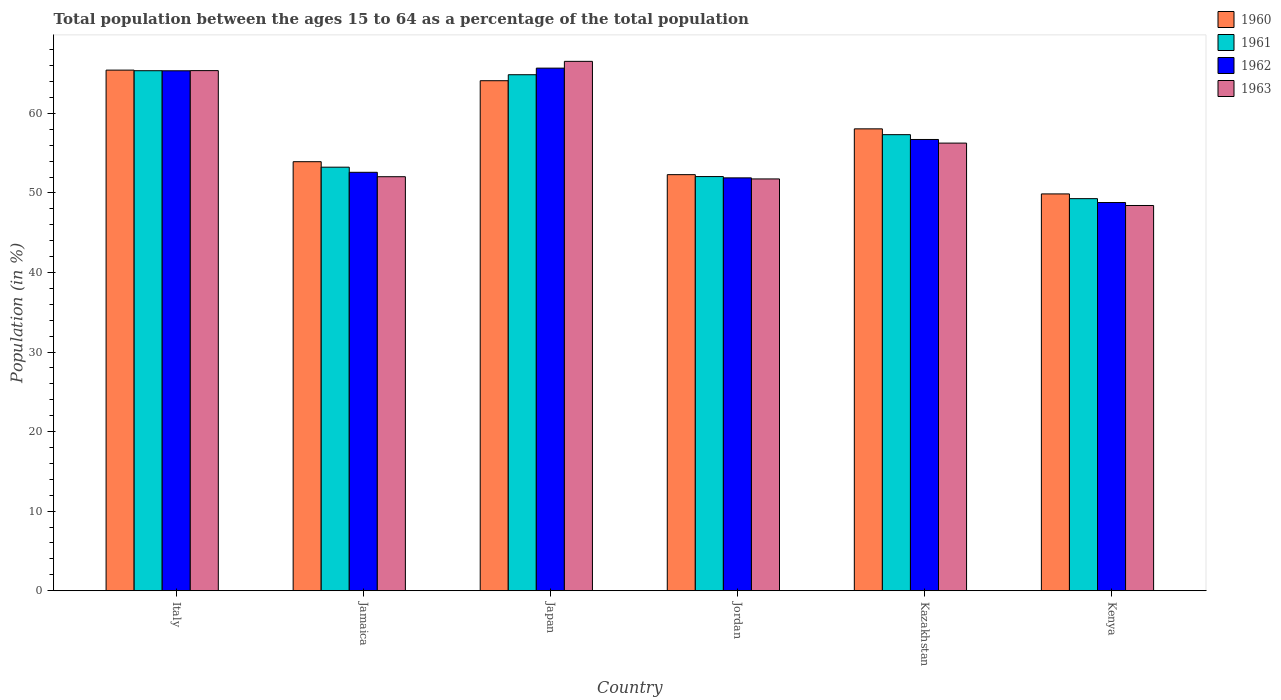How many different coloured bars are there?
Your answer should be compact. 4. Are the number of bars per tick equal to the number of legend labels?
Provide a short and direct response. Yes. How many bars are there on the 6th tick from the left?
Keep it short and to the point. 4. How many bars are there on the 2nd tick from the right?
Ensure brevity in your answer.  4. What is the label of the 5th group of bars from the left?
Make the answer very short. Kazakhstan. In how many cases, is the number of bars for a given country not equal to the number of legend labels?
Provide a short and direct response. 0. What is the percentage of the population ages 15 to 64 in 1960 in Jordan?
Give a very brief answer. 52.31. Across all countries, what is the maximum percentage of the population ages 15 to 64 in 1962?
Your response must be concise. 65.7. Across all countries, what is the minimum percentage of the population ages 15 to 64 in 1960?
Give a very brief answer. 49.88. In which country was the percentage of the population ages 15 to 64 in 1962 minimum?
Your answer should be very brief. Kenya. What is the total percentage of the population ages 15 to 64 in 1963 in the graph?
Ensure brevity in your answer.  340.45. What is the difference between the percentage of the population ages 15 to 64 in 1963 in Japan and that in Kazakhstan?
Give a very brief answer. 10.28. What is the difference between the percentage of the population ages 15 to 64 in 1963 in Kazakhstan and the percentage of the population ages 15 to 64 in 1960 in Jamaica?
Keep it short and to the point. 2.34. What is the average percentage of the population ages 15 to 64 in 1962 per country?
Offer a terse response. 56.85. What is the difference between the percentage of the population ages 15 to 64 of/in 1963 and percentage of the population ages 15 to 64 of/in 1962 in Japan?
Make the answer very short. 0.85. What is the ratio of the percentage of the population ages 15 to 64 in 1961 in Japan to that in Kazakhstan?
Provide a succinct answer. 1.13. Is the difference between the percentage of the population ages 15 to 64 in 1963 in Jordan and Kenya greater than the difference between the percentage of the population ages 15 to 64 in 1962 in Jordan and Kenya?
Your answer should be very brief. Yes. What is the difference between the highest and the second highest percentage of the population ages 15 to 64 in 1962?
Offer a terse response. -0.33. What is the difference between the highest and the lowest percentage of the population ages 15 to 64 in 1963?
Provide a succinct answer. 18.12. Is the sum of the percentage of the population ages 15 to 64 in 1962 in Jordan and Kenya greater than the maximum percentage of the population ages 15 to 64 in 1960 across all countries?
Keep it short and to the point. Yes. What does the 3rd bar from the left in Italy represents?
Ensure brevity in your answer.  1962. What does the 3rd bar from the right in Japan represents?
Keep it short and to the point. 1961. Is it the case that in every country, the sum of the percentage of the population ages 15 to 64 in 1960 and percentage of the population ages 15 to 64 in 1962 is greater than the percentage of the population ages 15 to 64 in 1963?
Your response must be concise. Yes. How many bars are there?
Offer a very short reply. 24. How many legend labels are there?
Offer a very short reply. 4. How are the legend labels stacked?
Keep it short and to the point. Vertical. What is the title of the graph?
Keep it short and to the point. Total population between the ages 15 to 64 as a percentage of the total population. Does "1995" appear as one of the legend labels in the graph?
Ensure brevity in your answer.  No. What is the label or title of the X-axis?
Your answer should be very brief. Country. What is the Population (in %) of 1960 in Italy?
Keep it short and to the point. 65.45. What is the Population (in %) of 1961 in Italy?
Provide a short and direct response. 65.37. What is the Population (in %) of 1962 in Italy?
Keep it short and to the point. 65.36. What is the Population (in %) in 1963 in Italy?
Make the answer very short. 65.38. What is the Population (in %) of 1960 in Jamaica?
Offer a very short reply. 53.93. What is the Population (in %) in 1961 in Jamaica?
Provide a succinct answer. 53.25. What is the Population (in %) of 1962 in Jamaica?
Offer a terse response. 52.6. What is the Population (in %) in 1963 in Jamaica?
Your answer should be very brief. 52.05. What is the Population (in %) of 1960 in Japan?
Your answer should be compact. 64.11. What is the Population (in %) of 1961 in Japan?
Provide a succinct answer. 64.87. What is the Population (in %) in 1962 in Japan?
Make the answer very short. 65.7. What is the Population (in %) of 1963 in Japan?
Keep it short and to the point. 66.55. What is the Population (in %) in 1960 in Jordan?
Offer a terse response. 52.31. What is the Population (in %) in 1961 in Jordan?
Your answer should be very brief. 52.06. What is the Population (in %) of 1962 in Jordan?
Your answer should be very brief. 51.9. What is the Population (in %) in 1963 in Jordan?
Provide a succinct answer. 51.77. What is the Population (in %) in 1960 in Kazakhstan?
Provide a short and direct response. 58.06. What is the Population (in %) in 1961 in Kazakhstan?
Your answer should be compact. 57.33. What is the Population (in %) of 1962 in Kazakhstan?
Your response must be concise. 56.73. What is the Population (in %) in 1963 in Kazakhstan?
Offer a very short reply. 56.27. What is the Population (in %) in 1960 in Kenya?
Provide a short and direct response. 49.88. What is the Population (in %) of 1961 in Kenya?
Your answer should be compact. 49.29. What is the Population (in %) in 1962 in Kenya?
Ensure brevity in your answer.  48.8. What is the Population (in %) in 1963 in Kenya?
Offer a very short reply. 48.43. Across all countries, what is the maximum Population (in %) of 1960?
Keep it short and to the point. 65.45. Across all countries, what is the maximum Population (in %) in 1961?
Offer a very short reply. 65.37. Across all countries, what is the maximum Population (in %) of 1962?
Keep it short and to the point. 65.7. Across all countries, what is the maximum Population (in %) of 1963?
Keep it short and to the point. 66.55. Across all countries, what is the minimum Population (in %) in 1960?
Make the answer very short. 49.88. Across all countries, what is the minimum Population (in %) of 1961?
Provide a succinct answer. 49.29. Across all countries, what is the minimum Population (in %) of 1962?
Provide a succinct answer. 48.8. Across all countries, what is the minimum Population (in %) in 1963?
Your answer should be very brief. 48.43. What is the total Population (in %) of 1960 in the graph?
Ensure brevity in your answer.  343.75. What is the total Population (in %) in 1961 in the graph?
Your response must be concise. 342.17. What is the total Population (in %) in 1962 in the graph?
Your answer should be very brief. 341.09. What is the total Population (in %) of 1963 in the graph?
Offer a very short reply. 340.45. What is the difference between the Population (in %) of 1960 in Italy and that in Jamaica?
Your answer should be compact. 11.51. What is the difference between the Population (in %) in 1961 in Italy and that in Jamaica?
Keep it short and to the point. 12.13. What is the difference between the Population (in %) in 1962 in Italy and that in Jamaica?
Your response must be concise. 12.76. What is the difference between the Population (in %) in 1963 in Italy and that in Jamaica?
Your answer should be compact. 13.34. What is the difference between the Population (in %) of 1960 in Italy and that in Japan?
Make the answer very short. 1.33. What is the difference between the Population (in %) in 1961 in Italy and that in Japan?
Make the answer very short. 0.5. What is the difference between the Population (in %) in 1962 in Italy and that in Japan?
Your response must be concise. -0.33. What is the difference between the Population (in %) in 1963 in Italy and that in Japan?
Ensure brevity in your answer.  -1.17. What is the difference between the Population (in %) in 1960 in Italy and that in Jordan?
Your answer should be compact. 13.14. What is the difference between the Population (in %) of 1961 in Italy and that in Jordan?
Provide a succinct answer. 13.31. What is the difference between the Population (in %) of 1962 in Italy and that in Jordan?
Offer a terse response. 13.46. What is the difference between the Population (in %) of 1963 in Italy and that in Jordan?
Offer a very short reply. 13.62. What is the difference between the Population (in %) in 1960 in Italy and that in Kazakhstan?
Provide a short and direct response. 7.38. What is the difference between the Population (in %) in 1961 in Italy and that in Kazakhstan?
Your answer should be compact. 8.04. What is the difference between the Population (in %) in 1962 in Italy and that in Kazakhstan?
Offer a very short reply. 8.64. What is the difference between the Population (in %) in 1963 in Italy and that in Kazakhstan?
Your answer should be compact. 9.11. What is the difference between the Population (in %) in 1960 in Italy and that in Kenya?
Provide a short and direct response. 15.56. What is the difference between the Population (in %) in 1961 in Italy and that in Kenya?
Give a very brief answer. 16.08. What is the difference between the Population (in %) of 1962 in Italy and that in Kenya?
Give a very brief answer. 16.56. What is the difference between the Population (in %) in 1963 in Italy and that in Kenya?
Your response must be concise. 16.96. What is the difference between the Population (in %) of 1960 in Jamaica and that in Japan?
Your answer should be compact. -10.18. What is the difference between the Population (in %) in 1961 in Jamaica and that in Japan?
Your answer should be very brief. -11.62. What is the difference between the Population (in %) in 1962 in Jamaica and that in Japan?
Give a very brief answer. -13.1. What is the difference between the Population (in %) in 1963 in Jamaica and that in Japan?
Make the answer very short. -14.5. What is the difference between the Population (in %) of 1960 in Jamaica and that in Jordan?
Provide a short and direct response. 1.63. What is the difference between the Population (in %) of 1961 in Jamaica and that in Jordan?
Give a very brief answer. 1.18. What is the difference between the Population (in %) in 1962 in Jamaica and that in Jordan?
Your response must be concise. 0.7. What is the difference between the Population (in %) of 1963 in Jamaica and that in Jordan?
Offer a terse response. 0.28. What is the difference between the Population (in %) in 1960 in Jamaica and that in Kazakhstan?
Offer a terse response. -4.13. What is the difference between the Population (in %) of 1961 in Jamaica and that in Kazakhstan?
Offer a terse response. -4.09. What is the difference between the Population (in %) of 1962 in Jamaica and that in Kazakhstan?
Provide a succinct answer. -4.13. What is the difference between the Population (in %) in 1963 in Jamaica and that in Kazakhstan?
Offer a terse response. -4.23. What is the difference between the Population (in %) in 1960 in Jamaica and that in Kenya?
Provide a succinct answer. 4.05. What is the difference between the Population (in %) in 1961 in Jamaica and that in Kenya?
Keep it short and to the point. 3.96. What is the difference between the Population (in %) in 1962 in Jamaica and that in Kenya?
Keep it short and to the point. 3.8. What is the difference between the Population (in %) in 1963 in Jamaica and that in Kenya?
Provide a short and direct response. 3.62. What is the difference between the Population (in %) of 1960 in Japan and that in Jordan?
Your answer should be very brief. 11.81. What is the difference between the Population (in %) in 1961 in Japan and that in Jordan?
Offer a very short reply. 12.8. What is the difference between the Population (in %) of 1962 in Japan and that in Jordan?
Your answer should be very brief. 13.8. What is the difference between the Population (in %) in 1963 in Japan and that in Jordan?
Offer a very short reply. 14.78. What is the difference between the Population (in %) of 1960 in Japan and that in Kazakhstan?
Ensure brevity in your answer.  6.05. What is the difference between the Population (in %) of 1961 in Japan and that in Kazakhstan?
Offer a very short reply. 7.53. What is the difference between the Population (in %) in 1962 in Japan and that in Kazakhstan?
Offer a terse response. 8.97. What is the difference between the Population (in %) of 1963 in Japan and that in Kazakhstan?
Provide a succinct answer. 10.28. What is the difference between the Population (in %) in 1960 in Japan and that in Kenya?
Your response must be concise. 14.23. What is the difference between the Population (in %) of 1961 in Japan and that in Kenya?
Ensure brevity in your answer.  15.58. What is the difference between the Population (in %) in 1962 in Japan and that in Kenya?
Make the answer very short. 16.89. What is the difference between the Population (in %) in 1963 in Japan and that in Kenya?
Your response must be concise. 18.12. What is the difference between the Population (in %) of 1960 in Jordan and that in Kazakhstan?
Keep it short and to the point. -5.76. What is the difference between the Population (in %) of 1961 in Jordan and that in Kazakhstan?
Offer a very short reply. -5.27. What is the difference between the Population (in %) in 1962 in Jordan and that in Kazakhstan?
Make the answer very short. -4.83. What is the difference between the Population (in %) of 1963 in Jordan and that in Kazakhstan?
Provide a short and direct response. -4.51. What is the difference between the Population (in %) of 1960 in Jordan and that in Kenya?
Offer a terse response. 2.42. What is the difference between the Population (in %) of 1961 in Jordan and that in Kenya?
Your answer should be compact. 2.78. What is the difference between the Population (in %) of 1962 in Jordan and that in Kenya?
Your answer should be very brief. 3.1. What is the difference between the Population (in %) in 1963 in Jordan and that in Kenya?
Ensure brevity in your answer.  3.34. What is the difference between the Population (in %) of 1960 in Kazakhstan and that in Kenya?
Provide a short and direct response. 8.18. What is the difference between the Population (in %) in 1961 in Kazakhstan and that in Kenya?
Make the answer very short. 8.04. What is the difference between the Population (in %) in 1962 in Kazakhstan and that in Kenya?
Keep it short and to the point. 7.93. What is the difference between the Population (in %) in 1963 in Kazakhstan and that in Kenya?
Offer a terse response. 7.84. What is the difference between the Population (in %) in 1960 in Italy and the Population (in %) in 1961 in Jamaica?
Give a very brief answer. 12.2. What is the difference between the Population (in %) in 1960 in Italy and the Population (in %) in 1962 in Jamaica?
Offer a terse response. 12.85. What is the difference between the Population (in %) in 1960 in Italy and the Population (in %) in 1963 in Jamaica?
Provide a short and direct response. 13.4. What is the difference between the Population (in %) of 1961 in Italy and the Population (in %) of 1962 in Jamaica?
Give a very brief answer. 12.77. What is the difference between the Population (in %) in 1961 in Italy and the Population (in %) in 1963 in Jamaica?
Offer a very short reply. 13.32. What is the difference between the Population (in %) of 1962 in Italy and the Population (in %) of 1963 in Jamaica?
Give a very brief answer. 13.32. What is the difference between the Population (in %) in 1960 in Italy and the Population (in %) in 1961 in Japan?
Provide a succinct answer. 0.58. What is the difference between the Population (in %) in 1960 in Italy and the Population (in %) in 1962 in Japan?
Provide a short and direct response. -0.25. What is the difference between the Population (in %) in 1960 in Italy and the Population (in %) in 1963 in Japan?
Offer a terse response. -1.1. What is the difference between the Population (in %) of 1961 in Italy and the Population (in %) of 1962 in Japan?
Your answer should be compact. -0.33. What is the difference between the Population (in %) of 1961 in Italy and the Population (in %) of 1963 in Japan?
Provide a succinct answer. -1.18. What is the difference between the Population (in %) in 1962 in Italy and the Population (in %) in 1963 in Japan?
Give a very brief answer. -1.19. What is the difference between the Population (in %) in 1960 in Italy and the Population (in %) in 1961 in Jordan?
Your answer should be very brief. 13.38. What is the difference between the Population (in %) in 1960 in Italy and the Population (in %) in 1962 in Jordan?
Offer a very short reply. 13.55. What is the difference between the Population (in %) of 1960 in Italy and the Population (in %) of 1963 in Jordan?
Give a very brief answer. 13.68. What is the difference between the Population (in %) of 1961 in Italy and the Population (in %) of 1962 in Jordan?
Your answer should be compact. 13.47. What is the difference between the Population (in %) in 1961 in Italy and the Population (in %) in 1963 in Jordan?
Keep it short and to the point. 13.6. What is the difference between the Population (in %) of 1962 in Italy and the Population (in %) of 1963 in Jordan?
Provide a succinct answer. 13.6. What is the difference between the Population (in %) in 1960 in Italy and the Population (in %) in 1961 in Kazakhstan?
Provide a succinct answer. 8.11. What is the difference between the Population (in %) in 1960 in Italy and the Population (in %) in 1962 in Kazakhstan?
Make the answer very short. 8.72. What is the difference between the Population (in %) of 1960 in Italy and the Population (in %) of 1963 in Kazakhstan?
Make the answer very short. 9.17. What is the difference between the Population (in %) of 1961 in Italy and the Population (in %) of 1962 in Kazakhstan?
Offer a terse response. 8.64. What is the difference between the Population (in %) in 1961 in Italy and the Population (in %) in 1963 in Kazakhstan?
Your response must be concise. 9.1. What is the difference between the Population (in %) in 1962 in Italy and the Population (in %) in 1963 in Kazakhstan?
Provide a short and direct response. 9.09. What is the difference between the Population (in %) of 1960 in Italy and the Population (in %) of 1961 in Kenya?
Your answer should be very brief. 16.16. What is the difference between the Population (in %) of 1960 in Italy and the Population (in %) of 1962 in Kenya?
Provide a short and direct response. 16.64. What is the difference between the Population (in %) in 1960 in Italy and the Population (in %) in 1963 in Kenya?
Give a very brief answer. 17.02. What is the difference between the Population (in %) of 1961 in Italy and the Population (in %) of 1962 in Kenya?
Offer a very short reply. 16.57. What is the difference between the Population (in %) of 1961 in Italy and the Population (in %) of 1963 in Kenya?
Give a very brief answer. 16.94. What is the difference between the Population (in %) in 1962 in Italy and the Population (in %) in 1963 in Kenya?
Your answer should be compact. 16.93. What is the difference between the Population (in %) of 1960 in Jamaica and the Population (in %) of 1961 in Japan?
Keep it short and to the point. -10.93. What is the difference between the Population (in %) in 1960 in Jamaica and the Population (in %) in 1962 in Japan?
Provide a short and direct response. -11.76. What is the difference between the Population (in %) of 1960 in Jamaica and the Population (in %) of 1963 in Japan?
Offer a terse response. -12.62. What is the difference between the Population (in %) in 1961 in Jamaica and the Population (in %) in 1962 in Japan?
Offer a very short reply. -12.45. What is the difference between the Population (in %) of 1961 in Jamaica and the Population (in %) of 1963 in Japan?
Your answer should be very brief. -13.3. What is the difference between the Population (in %) in 1962 in Jamaica and the Population (in %) in 1963 in Japan?
Give a very brief answer. -13.95. What is the difference between the Population (in %) of 1960 in Jamaica and the Population (in %) of 1961 in Jordan?
Make the answer very short. 1.87. What is the difference between the Population (in %) of 1960 in Jamaica and the Population (in %) of 1962 in Jordan?
Your answer should be compact. 2.03. What is the difference between the Population (in %) in 1960 in Jamaica and the Population (in %) in 1963 in Jordan?
Give a very brief answer. 2.17. What is the difference between the Population (in %) of 1961 in Jamaica and the Population (in %) of 1962 in Jordan?
Provide a succinct answer. 1.34. What is the difference between the Population (in %) in 1961 in Jamaica and the Population (in %) in 1963 in Jordan?
Provide a succinct answer. 1.48. What is the difference between the Population (in %) in 1962 in Jamaica and the Population (in %) in 1963 in Jordan?
Ensure brevity in your answer.  0.83. What is the difference between the Population (in %) in 1960 in Jamaica and the Population (in %) in 1961 in Kazakhstan?
Your response must be concise. -3.4. What is the difference between the Population (in %) of 1960 in Jamaica and the Population (in %) of 1962 in Kazakhstan?
Your response must be concise. -2.79. What is the difference between the Population (in %) of 1960 in Jamaica and the Population (in %) of 1963 in Kazakhstan?
Offer a very short reply. -2.34. What is the difference between the Population (in %) of 1961 in Jamaica and the Population (in %) of 1962 in Kazakhstan?
Provide a succinct answer. -3.48. What is the difference between the Population (in %) of 1961 in Jamaica and the Population (in %) of 1963 in Kazakhstan?
Provide a succinct answer. -3.03. What is the difference between the Population (in %) of 1962 in Jamaica and the Population (in %) of 1963 in Kazakhstan?
Keep it short and to the point. -3.67. What is the difference between the Population (in %) of 1960 in Jamaica and the Population (in %) of 1961 in Kenya?
Make the answer very short. 4.65. What is the difference between the Population (in %) of 1960 in Jamaica and the Population (in %) of 1962 in Kenya?
Your response must be concise. 5.13. What is the difference between the Population (in %) in 1960 in Jamaica and the Population (in %) in 1963 in Kenya?
Give a very brief answer. 5.51. What is the difference between the Population (in %) in 1961 in Jamaica and the Population (in %) in 1962 in Kenya?
Your answer should be compact. 4.44. What is the difference between the Population (in %) in 1961 in Jamaica and the Population (in %) in 1963 in Kenya?
Make the answer very short. 4.82. What is the difference between the Population (in %) of 1962 in Jamaica and the Population (in %) of 1963 in Kenya?
Offer a terse response. 4.17. What is the difference between the Population (in %) of 1960 in Japan and the Population (in %) of 1961 in Jordan?
Provide a succinct answer. 12.05. What is the difference between the Population (in %) of 1960 in Japan and the Population (in %) of 1962 in Jordan?
Keep it short and to the point. 12.21. What is the difference between the Population (in %) in 1960 in Japan and the Population (in %) in 1963 in Jordan?
Provide a short and direct response. 12.35. What is the difference between the Population (in %) in 1961 in Japan and the Population (in %) in 1962 in Jordan?
Your answer should be very brief. 12.97. What is the difference between the Population (in %) of 1961 in Japan and the Population (in %) of 1963 in Jordan?
Make the answer very short. 13.1. What is the difference between the Population (in %) in 1962 in Japan and the Population (in %) in 1963 in Jordan?
Your answer should be compact. 13.93. What is the difference between the Population (in %) in 1960 in Japan and the Population (in %) in 1961 in Kazakhstan?
Your answer should be very brief. 6.78. What is the difference between the Population (in %) of 1960 in Japan and the Population (in %) of 1962 in Kazakhstan?
Provide a short and direct response. 7.39. What is the difference between the Population (in %) in 1960 in Japan and the Population (in %) in 1963 in Kazakhstan?
Make the answer very short. 7.84. What is the difference between the Population (in %) in 1961 in Japan and the Population (in %) in 1962 in Kazakhstan?
Your answer should be very brief. 8.14. What is the difference between the Population (in %) in 1961 in Japan and the Population (in %) in 1963 in Kazakhstan?
Provide a short and direct response. 8.59. What is the difference between the Population (in %) in 1962 in Japan and the Population (in %) in 1963 in Kazakhstan?
Provide a succinct answer. 9.42. What is the difference between the Population (in %) of 1960 in Japan and the Population (in %) of 1961 in Kenya?
Provide a succinct answer. 14.83. What is the difference between the Population (in %) in 1960 in Japan and the Population (in %) in 1962 in Kenya?
Your answer should be compact. 15.31. What is the difference between the Population (in %) in 1960 in Japan and the Population (in %) in 1963 in Kenya?
Ensure brevity in your answer.  15.69. What is the difference between the Population (in %) in 1961 in Japan and the Population (in %) in 1962 in Kenya?
Ensure brevity in your answer.  16.06. What is the difference between the Population (in %) in 1961 in Japan and the Population (in %) in 1963 in Kenya?
Provide a short and direct response. 16.44. What is the difference between the Population (in %) in 1962 in Japan and the Population (in %) in 1963 in Kenya?
Your response must be concise. 17.27. What is the difference between the Population (in %) of 1960 in Jordan and the Population (in %) of 1961 in Kazakhstan?
Your answer should be very brief. -5.03. What is the difference between the Population (in %) of 1960 in Jordan and the Population (in %) of 1962 in Kazakhstan?
Your answer should be very brief. -4.42. What is the difference between the Population (in %) of 1960 in Jordan and the Population (in %) of 1963 in Kazakhstan?
Your answer should be compact. -3.97. What is the difference between the Population (in %) of 1961 in Jordan and the Population (in %) of 1962 in Kazakhstan?
Give a very brief answer. -4.66. What is the difference between the Population (in %) of 1961 in Jordan and the Population (in %) of 1963 in Kazakhstan?
Your answer should be very brief. -4.21. What is the difference between the Population (in %) in 1962 in Jordan and the Population (in %) in 1963 in Kazakhstan?
Provide a succinct answer. -4.37. What is the difference between the Population (in %) in 1960 in Jordan and the Population (in %) in 1961 in Kenya?
Provide a short and direct response. 3.02. What is the difference between the Population (in %) in 1960 in Jordan and the Population (in %) in 1962 in Kenya?
Provide a short and direct response. 3.5. What is the difference between the Population (in %) of 1960 in Jordan and the Population (in %) of 1963 in Kenya?
Offer a very short reply. 3.88. What is the difference between the Population (in %) in 1961 in Jordan and the Population (in %) in 1962 in Kenya?
Ensure brevity in your answer.  3.26. What is the difference between the Population (in %) of 1961 in Jordan and the Population (in %) of 1963 in Kenya?
Give a very brief answer. 3.63. What is the difference between the Population (in %) of 1962 in Jordan and the Population (in %) of 1963 in Kenya?
Make the answer very short. 3.47. What is the difference between the Population (in %) in 1960 in Kazakhstan and the Population (in %) in 1961 in Kenya?
Offer a very short reply. 8.78. What is the difference between the Population (in %) in 1960 in Kazakhstan and the Population (in %) in 1962 in Kenya?
Provide a succinct answer. 9.26. What is the difference between the Population (in %) of 1960 in Kazakhstan and the Population (in %) of 1963 in Kenya?
Ensure brevity in your answer.  9.63. What is the difference between the Population (in %) in 1961 in Kazakhstan and the Population (in %) in 1962 in Kenya?
Your response must be concise. 8.53. What is the difference between the Population (in %) in 1961 in Kazakhstan and the Population (in %) in 1963 in Kenya?
Give a very brief answer. 8.9. What is the difference between the Population (in %) of 1962 in Kazakhstan and the Population (in %) of 1963 in Kenya?
Your answer should be compact. 8.3. What is the average Population (in %) of 1960 per country?
Your answer should be very brief. 57.29. What is the average Population (in %) in 1961 per country?
Your answer should be very brief. 57.03. What is the average Population (in %) of 1962 per country?
Your answer should be compact. 56.85. What is the average Population (in %) of 1963 per country?
Make the answer very short. 56.74. What is the difference between the Population (in %) in 1960 and Population (in %) in 1961 in Italy?
Your response must be concise. 0.08. What is the difference between the Population (in %) of 1960 and Population (in %) of 1962 in Italy?
Make the answer very short. 0.08. What is the difference between the Population (in %) in 1960 and Population (in %) in 1963 in Italy?
Give a very brief answer. 0.06. What is the difference between the Population (in %) of 1961 and Population (in %) of 1962 in Italy?
Provide a succinct answer. 0.01. What is the difference between the Population (in %) in 1961 and Population (in %) in 1963 in Italy?
Your answer should be compact. -0.01. What is the difference between the Population (in %) of 1962 and Population (in %) of 1963 in Italy?
Keep it short and to the point. -0.02. What is the difference between the Population (in %) of 1960 and Population (in %) of 1961 in Jamaica?
Your answer should be compact. 0.69. What is the difference between the Population (in %) in 1960 and Population (in %) in 1962 in Jamaica?
Keep it short and to the point. 1.33. What is the difference between the Population (in %) of 1960 and Population (in %) of 1963 in Jamaica?
Provide a succinct answer. 1.89. What is the difference between the Population (in %) in 1961 and Population (in %) in 1962 in Jamaica?
Make the answer very short. 0.65. What is the difference between the Population (in %) of 1961 and Population (in %) of 1963 in Jamaica?
Offer a very short reply. 1.2. What is the difference between the Population (in %) of 1962 and Population (in %) of 1963 in Jamaica?
Provide a short and direct response. 0.55. What is the difference between the Population (in %) in 1960 and Population (in %) in 1961 in Japan?
Provide a succinct answer. -0.75. What is the difference between the Population (in %) in 1960 and Population (in %) in 1962 in Japan?
Give a very brief answer. -1.58. What is the difference between the Population (in %) in 1960 and Population (in %) in 1963 in Japan?
Offer a very short reply. -2.43. What is the difference between the Population (in %) of 1961 and Population (in %) of 1962 in Japan?
Make the answer very short. -0.83. What is the difference between the Population (in %) in 1961 and Population (in %) in 1963 in Japan?
Provide a short and direct response. -1.68. What is the difference between the Population (in %) in 1962 and Population (in %) in 1963 in Japan?
Make the answer very short. -0.85. What is the difference between the Population (in %) in 1960 and Population (in %) in 1961 in Jordan?
Provide a short and direct response. 0.24. What is the difference between the Population (in %) of 1960 and Population (in %) of 1962 in Jordan?
Make the answer very short. 0.4. What is the difference between the Population (in %) of 1960 and Population (in %) of 1963 in Jordan?
Make the answer very short. 0.54. What is the difference between the Population (in %) in 1961 and Population (in %) in 1962 in Jordan?
Your answer should be very brief. 0.16. What is the difference between the Population (in %) in 1961 and Population (in %) in 1963 in Jordan?
Your response must be concise. 0.3. What is the difference between the Population (in %) of 1962 and Population (in %) of 1963 in Jordan?
Make the answer very short. 0.13. What is the difference between the Population (in %) in 1960 and Population (in %) in 1961 in Kazakhstan?
Ensure brevity in your answer.  0.73. What is the difference between the Population (in %) in 1960 and Population (in %) in 1962 in Kazakhstan?
Your answer should be very brief. 1.34. What is the difference between the Population (in %) in 1960 and Population (in %) in 1963 in Kazakhstan?
Provide a short and direct response. 1.79. What is the difference between the Population (in %) in 1961 and Population (in %) in 1962 in Kazakhstan?
Your answer should be compact. 0.61. What is the difference between the Population (in %) of 1961 and Population (in %) of 1963 in Kazakhstan?
Make the answer very short. 1.06. What is the difference between the Population (in %) in 1962 and Population (in %) in 1963 in Kazakhstan?
Your response must be concise. 0.46. What is the difference between the Population (in %) of 1960 and Population (in %) of 1961 in Kenya?
Provide a succinct answer. 0.6. What is the difference between the Population (in %) in 1960 and Population (in %) in 1962 in Kenya?
Keep it short and to the point. 1.08. What is the difference between the Population (in %) in 1960 and Population (in %) in 1963 in Kenya?
Make the answer very short. 1.46. What is the difference between the Population (in %) of 1961 and Population (in %) of 1962 in Kenya?
Provide a succinct answer. 0.49. What is the difference between the Population (in %) in 1961 and Population (in %) in 1963 in Kenya?
Give a very brief answer. 0.86. What is the difference between the Population (in %) in 1962 and Population (in %) in 1963 in Kenya?
Your response must be concise. 0.37. What is the ratio of the Population (in %) in 1960 in Italy to that in Jamaica?
Keep it short and to the point. 1.21. What is the ratio of the Population (in %) of 1961 in Italy to that in Jamaica?
Provide a short and direct response. 1.23. What is the ratio of the Population (in %) of 1962 in Italy to that in Jamaica?
Offer a very short reply. 1.24. What is the ratio of the Population (in %) of 1963 in Italy to that in Jamaica?
Ensure brevity in your answer.  1.26. What is the ratio of the Population (in %) in 1960 in Italy to that in Japan?
Your answer should be compact. 1.02. What is the ratio of the Population (in %) of 1962 in Italy to that in Japan?
Your response must be concise. 0.99. What is the ratio of the Population (in %) of 1963 in Italy to that in Japan?
Provide a succinct answer. 0.98. What is the ratio of the Population (in %) of 1960 in Italy to that in Jordan?
Provide a succinct answer. 1.25. What is the ratio of the Population (in %) of 1961 in Italy to that in Jordan?
Your response must be concise. 1.26. What is the ratio of the Population (in %) in 1962 in Italy to that in Jordan?
Give a very brief answer. 1.26. What is the ratio of the Population (in %) of 1963 in Italy to that in Jordan?
Your answer should be very brief. 1.26. What is the ratio of the Population (in %) in 1960 in Italy to that in Kazakhstan?
Your answer should be compact. 1.13. What is the ratio of the Population (in %) in 1961 in Italy to that in Kazakhstan?
Keep it short and to the point. 1.14. What is the ratio of the Population (in %) in 1962 in Italy to that in Kazakhstan?
Provide a succinct answer. 1.15. What is the ratio of the Population (in %) in 1963 in Italy to that in Kazakhstan?
Give a very brief answer. 1.16. What is the ratio of the Population (in %) of 1960 in Italy to that in Kenya?
Give a very brief answer. 1.31. What is the ratio of the Population (in %) in 1961 in Italy to that in Kenya?
Keep it short and to the point. 1.33. What is the ratio of the Population (in %) of 1962 in Italy to that in Kenya?
Keep it short and to the point. 1.34. What is the ratio of the Population (in %) in 1963 in Italy to that in Kenya?
Provide a succinct answer. 1.35. What is the ratio of the Population (in %) of 1960 in Jamaica to that in Japan?
Ensure brevity in your answer.  0.84. What is the ratio of the Population (in %) of 1961 in Jamaica to that in Japan?
Provide a succinct answer. 0.82. What is the ratio of the Population (in %) of 1962 in Jamaica to that in Japan?
Your answer should be compact. 0.8. What is the ratio of the Population (in %) of 1963 in Jamaica to that in Japan?
Keep it short and to the point. 0.78. What is the ratio of the Population (in %) of 1960 in Jamaica to that in Jordan?
Your answer should be compact. 1.03. What is the ratio of the Population (in %) of 1961 in Jamaica to that in Jordan?
Offer a terse response. 1.02. What is the ratio of the Population (in %) of 1962 in Jamaica to that in Jordan?
Provide a succinct answer. 1.01. What is the ratio of the Population (in %) in 1963 in Jamaica to that in Jordan?
Your answer should be very brief. 1.01. What is the ratio of the Population (in %) in 1960 in Jamaica to that in Kazakhstan?
Your answer should be very brief. 0.93. What is the ratio of the Population (in %) in 1961 in Jamaica to that in Kazakhstan?
Make the answer very short. 0.93. What is the ratio of the Population (in %) in 1962 in Jamaica to that in Kazakhstan?
Make the answer very short. 0.93. What is the ratio of the Population (in %) of 1963 in Jamaica to that in Kazakhstan?
Offer a terse response. 0.92. What is the ratio of the Population (in %) in 1960 in Jamaica to that in Kenya?
Keep it short and to the point. 1.08. What is the ratio of the Population (in %) of 1961 in Jamaica to that in Kenya?
Provide a short and direct response. 1.08. What is the ratio of the Population (in %) of 1962 in Jamaica to that in Kenya?
Offer a very short reply. 1.08. What is the ratio of the Population (in %) in 1963 in Jamaica to that in Kenya?
Give a very brief answer. 1.07. What is the ratio of the Population (in %) of 1960 in Japan to that in Jordan?
Make the answer very short. 1.23. What is the ratio of the Population (in %) in 1961 in Japan to that in Jordan?
Make the answer very short. 1.25. What is the ratio of the Population (in %) of 1962 in Japan to that in Jordan?
Offer a very short reply. 1.27. What is the ratio of the Population (in %) of 1963 in Japan to that in Jordan?
Your answer should be very brief. 1.29. What is the ratio of the Population (in %) in 1960 in Japan to that in Kazakhstan?
Provide a succinct answer. 1.1. What is the ratio of the Population (in %) of 1961 in Japan to that in Kazakhstan?
Ensure brevity in your answer.  1.13. What is the ratio of the Population (in %) of 1962 in Japan to that in Kazakhstan?
Give a very brief answer. 1.16. What is the ratio of the Population (in %) of 1963 in Japan to that in Kazakhstan?
Your answer should be very brief. 1.18. What is the ratio of the Population (in %) of 1960 in Japan to that in Kenya?
Offer a very short reply. 1.29. What is the ratio of the Population (in %) in 1961 in Japan to that in Kenya?
Your answer should be very brief. 1.32. What is the ratio of the Population (in %) of 1962 in Japan to that in Kenya?
Your answer should be very brief. 1.35. What is the ratio of the Population (in %) of 1963 in Japan to that in Kenya?
Provide a succinct answer. 1.37. What is the ratio of the Population (in %) of 1960 in Jordan to that in Kazakhstan?
Provide a succinct answer. 0.9. What is the ratio of the Population (in %) in 1961 in Jordan to that in Kazakhstan?
Provide a succinct answer. 0.91. What is the ratio of the Population (in %) of 1962 in Jordan to that in Kazakhstan?
Ensure brevity in your answer.  0.91. What is the ratio of the Population (in %) in 1963 in Jordan to that in Kazakhstan?
Your answer should be compact. 0.92. What is the ratio of the Population (in %) of 1960 in Jordan to that in Kenya?
Keep it short and to the point. 1.05. What is the ratio of the Population (in %) of 1961 in Jordan to that in Kenya?
Your answer should be very brief. 1.06. What is the ratio of the Population (in %) in 1962 in Jordan to that in Kenya?
Offer a very short reply. 1.06. What is the ratio of the Population (in %) in 1963 in Jordan to that in Kenya?
Offer a terse response. 1.07. What is the ratio of the Population (in %) of 1960 in Kazakhstan to that in Kenya?
Offer a terse response. 1.16. What is the ratio of the Population (in %) of 1961 in Kazakhstan to that in Kenya?
Make the answer very short. 1.16. What is the ratio of the Population (in %) of 1962 in Kazakhstan to that in Kenya?
Offer a very short reply. 1.16. What is the ratio of the Population (in %) of 1963 in Kazakhstan to that in Kenya?
Your answer should be very brief. 1.16. What is the difference between the highest and the second highest Population (in %) of 1960?
Offer a very short reply. 1.33. What is the difference between the highest and the second highest Population (in %) of 1961?
Your answer should be compact. 0.5. What is the difference between the highest and the second highest Population (in %) in 1962?
Your answer should be very brief. 0.33. What is the difference between the highest and the second highest Population (in %) of 1963?
Your response must be concise. 1.17. What is the difference between the highest and the lowest Population (in %) of 1960?
Your answer should be very brief. 15.56. What is the difference between the highest and the lowest Population (in %) of 1961?
Offer a very short reply. 16.08. What is the difference between the highest and the lowest Population (in %) of 1962?
Offer a terse response. 16.89. What is the difference between the highest and the lowest Population (in %) in 1963?
Your answer should be very brief. 18.12. 